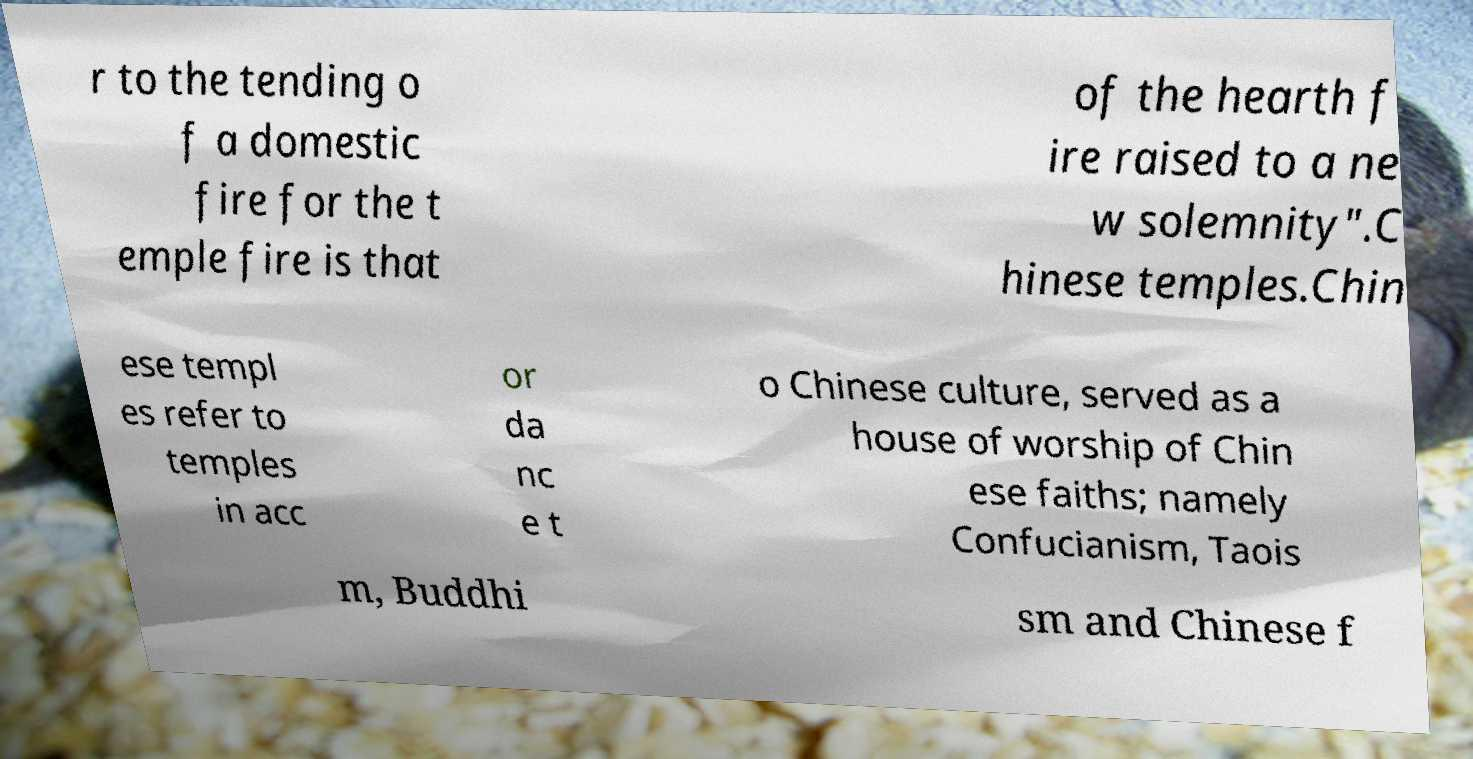Can you accurately transcribe the text from the provided image for me? r to the tending o f a domestic fire for the t emple fire is that of the hearth f ire raised to a ne w solemnity".C hinese temples.Chin ese templ es refer to temples in acc or da nc e t o Chinese culture, served as a house of worship of Chin ese faiths; namely Confucianism, Taois m, Buddhi sm and Chinese f 